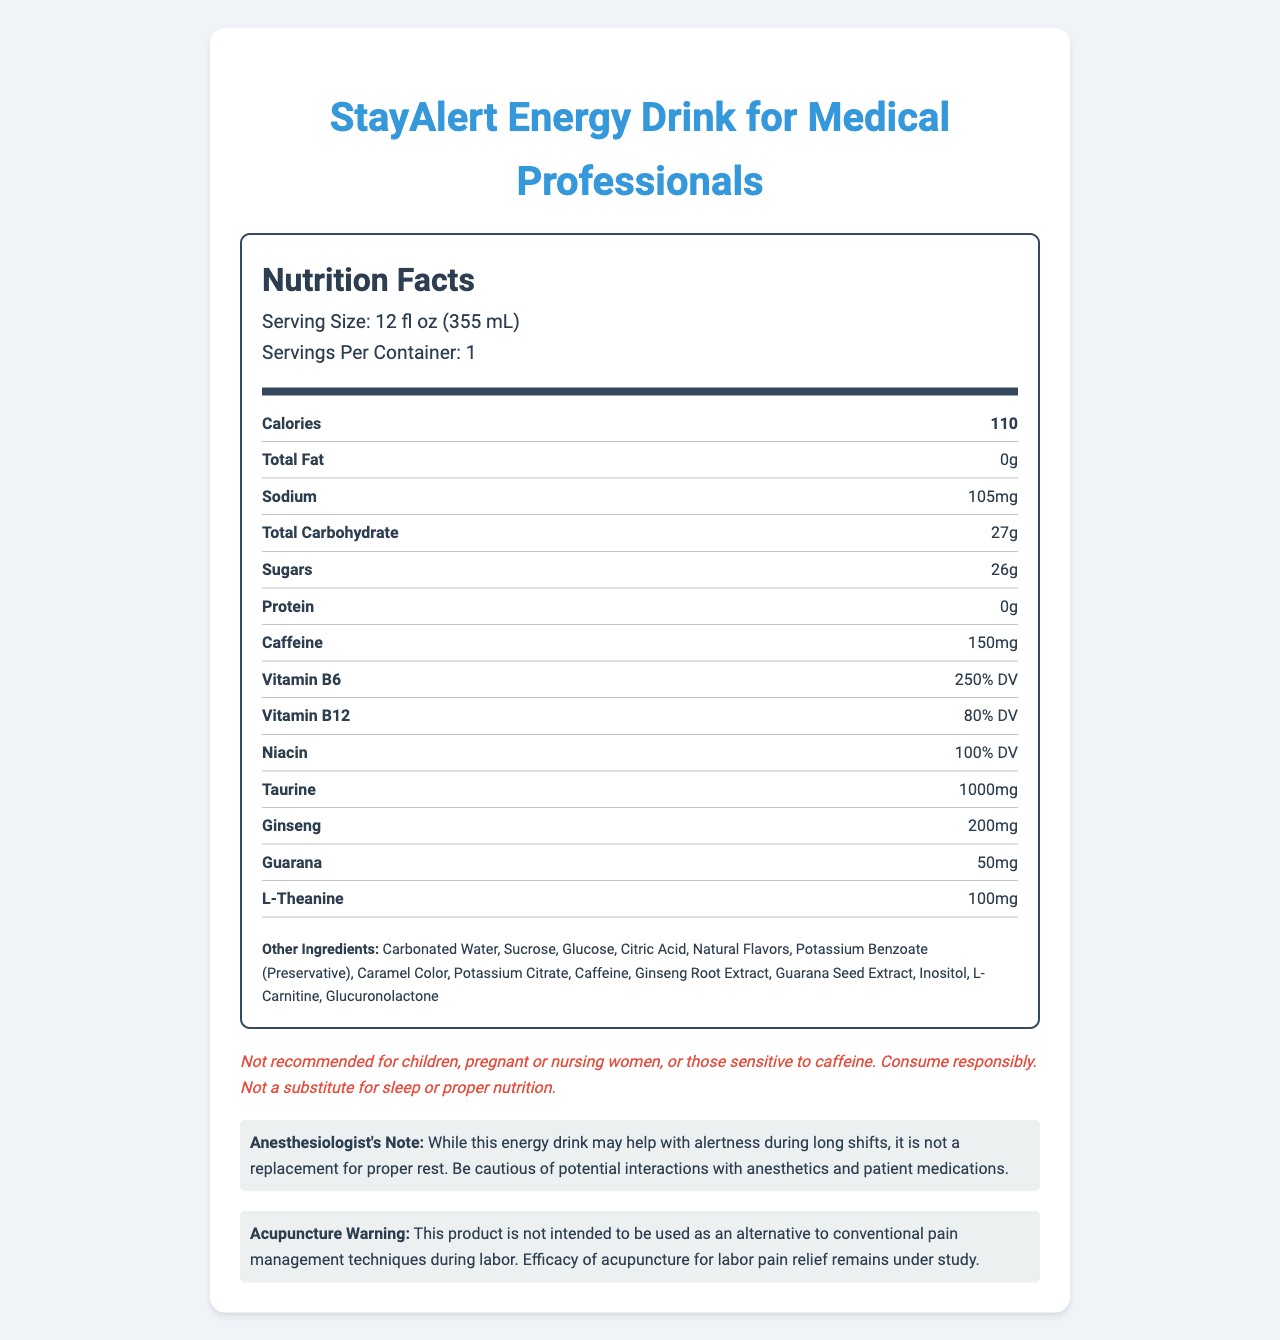what is the serving size of StayAlert Energy Drink for Medical Professionals? The serving size is provided at the top of the nutrition facts label and is stated as 12 fl oz (355 mL).
Answer: 12 fl oz (355 mL) how many calories are in one serving? The number of calories per serving is listed in bold under the nutrition facts section.
Answer: 110 how much caffeine does one serving of the drink contain? The amount of caffeine per serving is explicitly mentioned in the nutrient rows of the nutrition facts label.
Answer: 150mg what is the percentage daily value (% DV) of Vitamin B6 per serving? The % DV of Vitamin B6 is indicated in the nutrient rows under the nutrition facts, specifying it as 250%.
Answer: 250% how much sugar is in one serving of the drink? The sugar content per serving is listed as 26g in the nutrient rows of the nutrition facts.
Answer: 26g is this product recommended for children? The disclaimer at the bottom of the document states that it is not recommended for children.
Answer: No which ingredient is listed first in the list of other ingredients? A. Citric Acid B. Sucrose C. Carbonated Water D. Inositol The list of other ingredients starts with Carbonated Water.
Answer: C. Carbonated Water what is the sodium content in one serving? The sodium content per serving is listed in the nutrient rows with a value of 105mg.
Answer: 105mg which statement is true about this energy drink? A. It contains 200mg of Taurine B. It has 200% DV of Vitamin B12 C. It contains 100g of sugars D. It has zero protein According to the nutrient rows, this energy drink contains 0g of protein.
Answer: D. It has zero protein should pregnant women consume this product? The disclaimer clearly states that the product is not recommended for pregnant or nursing women.
Answer: No what is not mentioned in the acupuncture warning? The acupuncture warning mentions that the product should not be used as an alternative to conventional pain management techniques during labor and notes that the efficacy of acupuncture for labor pain relief remains under study.
Answer: Alternative pain management techniques describe the main idea of the document The explanation details the overall structure and key information presented in the document, including nutritional values, ingredients, specific disclaimers, and professional notes.
Answer: The document provides the nutrition facts, ingredients, and disclaimers for the StayAlert Energy Drink for Medical Professionals. It highlights the nutritional content per serving, including calories, sugars, caffeine, vitamins, and other ingredients. It also includes specific notes for anesthesiologists and warnings regarding the use of this product by certain populations. 